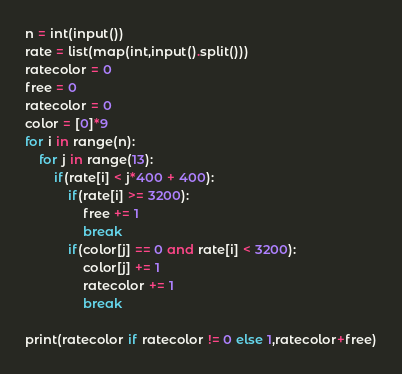<code> <loc_0><loc_0><loc_500><loc_500><_Python_>n = int(input())
rate = list(map(int,input().split()))
ratecolor = 0
free = 0
ratecolor = 0
color = [0]*9
for i in range(n):
    for j in range(13):
        if(rate[i] < j*400 + 400):
            if(rate[i] >= 3200):
                free += 1
                break
            if(color[j] == 0 and rate[i] < 3200):
                color[j] += 1
                ratecolor += 1
                break

print(ratecolor if ratecolor != 0 else 1,ratecolor+free)

</code> 